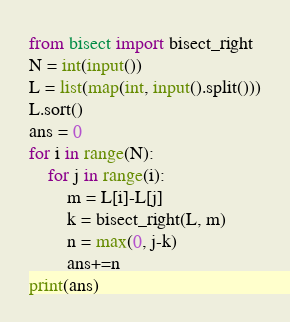Convert code to text. <code><loc_0><loc_0><loc_500><loc_500><_Python_>from bisect import bisect_right
N = int(input())
L = list(map(int, input().split()))
L.sort()
ans = 0
for i in range(N):
    for j in range(i):
        m = L[i]-L[j]
        k = bisect_right(L, m)
        n = max(0, j-k)
        ans+=n
print(ans)</code> 